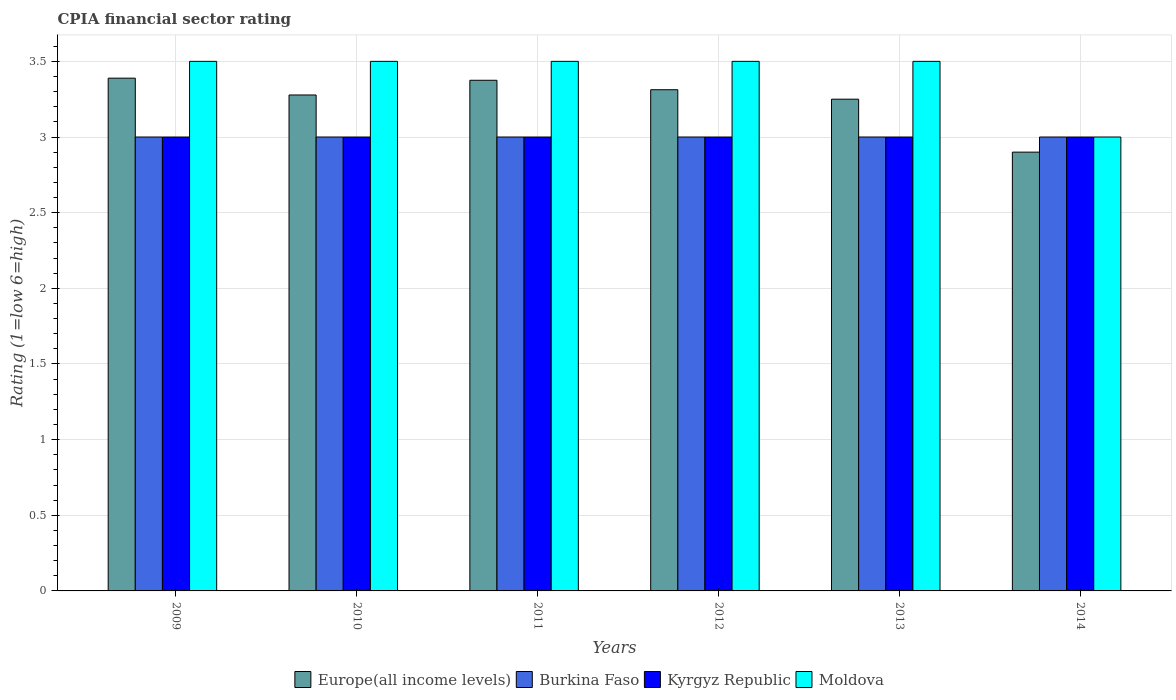How many groups of bars are there?
Offer a very short reply. 6. Are the number of bars per tick equal to the number of legend labels?
Offer a very short reply. Yes. Are the number of bars on each tick of the X-axis equal?
Your answer should be very brief. Yes. Across all years, what is the maximum CPIA rating in Burkina Faso?
Provide a succinct answer. 3. In which year was the CPIA rating in Burkina Faso maximum?
Your response must be concise. 2009. What is the total CPIA rating in Kyrgyz Republic in the graph?
Give a very brief answer. 18. What is the average CPIA rating in Moldova per year?
Provide a succinct answer. 3.42. What is the ratio of the CPIA rating in Kyrgyz Republic in 2009 to that in 2010?
Your answer should be compact. 1. Is the difference between the CPIA rating in Burkina Faso in 2010 and 2013 greater than the difference between the CPIA rating in Europe(all income levels) in 2010 and 2013?
Ensure brevity in your answer.  No. What is the difference between the highest and the second highest CPIA rating in Burkina Faso?
Provide a short and direct response. 0. What is the difference between the highest and the lowest CPIA rating in Europe(all income levels)?
Offer a terse response. 0.49. Is it the case that in every year, the sum of the CPIA rating in Kyrgyz Republic and CPIA rating in Moldova is greater than the sum of CPIA rating in Burkina Faso and CPIA rating in Europe(all income levels)?
Give a very brief answer. No. What does the 3rd bar from the left in 2012 represents?
Make the answer very short. Kyrgyz Republic. What does the 4th bar from the right in 2011 represents?
Your answer should be compact. Europe(all income levels). Is it the case that in every year, the sum of the CPIA rating in Moldova and CPIA rating in Europe(all income levels) is greater than the CPIA rating in Kyrgyz Republic?
Your answer should be compact. Yes. How many bars are there?
Ensure brevity in your answer.  24. How many years are there in the graph?
Give a very brief answer. 6. How many legend labels are there?
Make the answer very short. 4. What is the title of the graph?
Offer a very short reply. CPIA financial sector rating. What is the label or title of the Y-axis?
Keep it short and to the point. Rating (1=low 6=high). What is the Rating (1=low 6=high) of Europe(all income levels) in 2009?
Your answer should be compact. 3.39. What is the Rating (1=low 6=high) in Kyrgyz Republic in 2009?
Provide a succinct answer. 3. What is the Rating (1=low 6=high) in Moldova in 2009?
Provide a short and direct response. 3.5. What is the Rating (1=low 6=high) in Europe(all income levels) in 2010?
Ensure brevity in your answer.  3.28. What is the Rating (1=low 6=high) in Burkina Faso in 2010?
Offer a terse response. 3. What is the Rating (1=low 6=high) in Moldova in 2010?
Offer a terse response. 3.5. What is the Rating (1=low 6=high) in Europe(all income levels) in 2011?
Your answer should be compact. 3.38. What is the Rating (1=low 6=high) of Moldova in 2011?
Your answer should be compact. 3.5. What is the Rating (1=low 6=high) of Europe(all income levels) in 2012?
Ensure brevity in your answer.  3.31. What is the Rating (1=low 6=high) of Kyrgyz Republic in 2012?
Offer a very short reply. 3. What is the Rating (1=low 6=high) of Europe(all income levels) in 2013?
Ensure brevity in your answer.  3.25. What is the Rating (1=low 6=high) of Kyrgyz Republic in 2013?
Your answer should be very brief. 3. What is the Rating (1=low 6=high) of Moldova in 2013?
Make the answer very short. 3.5. What is the Rating (1=low 6=high) of Europe(all income levels) in 2014?
Make the answer very short. 2.9. What is the Rating (1=low 6=high) in Burkina Faso in 2014?
Provide a short and direct response. 3. What is the Rating (1=low 6=high) in Kyrgyz Republic in 2014?
Your answer should be very brief. 3. Across all years, what is the maximum Rating (1=low 6=high) in Europe(all income levels)?
Ensure brevity in your answer.  3.39. Across all years, what is the maximum Rating (1=low 6=high) of Kyrgyz Republic?
Provide a succinct answer. 3. Across all years, what is the maximum Rating (1=low 6=high) of Moldova?
Give a very brief answer. 3.5. Across all years, what is the minimum Rating (1=low 6=high) in Europe(all income levels)?
Your response must be concise. 2.9. What is the total Rating (1=low 6=high) of Europe(all income levels) in the graph?
Provide a succinct answer. 19.5. What is the total Rating (1=low 6=high) in Burkina Faso in the graph?
Offer a very short reply. 18. What is the difference between the Rating (1=low 6=high) in Kyrgyz Republic in 2009 and that in 2010?
Your response must be concise. 0. What is the difference between the Rating (1=low 6=high) in Moldova in 2009 and that in 2010?
Your response must be concise. 0. What is the difference between the Rating (1=low 6=high) in Europe(all income levels) in 2009 and that in 2011?
Your response must be concise. 0.01. What is the difference between the Rating (1=low 6=high) of Moldova in 2009 and that in 2011?
Provide a succinct answer. 0. What is the difference between the Rating (1=low 6=high) in Europe(all income levels) in 2009 and that in 2012?
Offer a terse response. 0.08. What is the difference between the Rating (1=low 6=high) in Burkina Faso in 2009 and that in 2012?
Offer a very short reply. 0. What is the difference between the Rating (1=low 6=high) in Kyrgyz Republic in 2009 and that in 2012?
Keep it short and to the point. 0. What is the difference between the Rating (1=low 6=high) of Moldova in 2009 and that in 2012?
Your answer should be compact. 0. What is the difference between the Rating (1=low 6=high) of Europe(all income levels) in 2009 and that in 2013?
Keep it short and to the point. 0.14. What is the difference between the Rating (1=low 6=high) of Burkina Faso in 2009 and that in 2013?
Your response must be concise. 0. What is the difference between the Rating (1=low 6=high) of Moldova in 2009 and that in 2013?
Keep it short and to the point. 0. What is the difference between the Rating (1=low 6=high) of Europe(all income levels) in 2009 and that in 2014?
Offer a terse response. 0.49. What is the difference between the Rating (1=low 6=high) in Burkina Faso in 2009 and that in 2014?
Offer a very short reply. 0. What is the difference between the Rating (1=low 6=high) in Europe(all income levels) in 2010 and that in 2011?
Your answer should be compact. -0.1. What is the difference between the Rating (1=low 6=high) in Burkina Faso in 2010 and that in 2011?
Offer a very short reply. 0. What is the difference between the Rating (1=low 6=high) of Kyrgyz Republic in 2010 and that in 2011?
Your answer should be compact. 0. What is the difference between the Rating (1=low 6=high) of Moldova in 2010 and that in 2011?
Offer a terse response. 0. What is the difference between the Rating (1=low 6=high) in Europe(all income levels) in 2010 and that in 2012?
Your answer should be very brief. -0.03. What is the difference between the Rating (1=low 6=high) of Kyrgyz Republic in 2010 and that in 2012?
Your answer should be very brief. 0. What is the difference between the Rating (1=low 6=high) of Europe(all income levels) in 2010 and that in 2013?
Your answer should be very brief. 0.03. What is the difference between the Rating (1=low 6=high) of Kyrgyz Republic in 2010 and that in 2013?
Your response must be concise. 0. What is the difference between the Rating (1=low 6=high) in Moldova in 2010 and that in 2013?
Offer a very short reply. 0. What is the difference between the Rating (1=low 6=high) of Europe(all income levels) in 2010 and that in 2014?
Offer a very short reply. 0.38. What is the difference between the Rating (1=low 6=high) in Burkina Faso in 2010 and that in 2014?
Make the answer very short. 0. What is the difference between the Rating (1=low 6=high) of Kyrgyz Republic in 2010 and that in 2014?
Provide a short and direct response. 0. What is the difference between the Rating (1=low 6=high) of Moldova in 2010 and that in 2014?
Ensure brevity in your answer.  0.5. What is the difference between the Rating (1=low 6=high) of Europe(all income levels) in 2011 and that in 2012?
Your answer should be compact. 0.06. What is the difference between the Rating (1=low 6=high) of Burkina Faso in 2011 and that in 2012?
Make the answer very short. 0. What is the difference between the Rating (1=low 6=high) of Europe(all income levels) in 2011 and that in 2013?
Provide a succinct answer. 0.12. What is the difference between the Rating (1=low 6=high) in Burkina Faso in 2011 and that in 2013?
Provide a short and direct response. 0. What is the difference between the Rating (1=low 6=high) of Kyrgyz Republic in 2011 and that in 2013?
Provide a succinct answer. 0. What is the difference between the Rating (1=low 6=high) in Moldova in 2011 and that in 2013?
Keep it short and to the point. 0. What is the difference between the Rating (1=low 6=high) of Europe(all income levels) in 2011 and that in 2014?
Keep it short and to the point. 0.47. What is the difference between the Rating (1=low 6=high) of Kyrgyz Republic in 2011 and that in 2014?
Provide a short and direct response. 0. What is the difference between the Rating (1=low 6=high) of Moldova in 2011 and that in 2014?
Your response must be concise. 0.5. What is the difference between the Rating (1=low 6=high) of Europe(all income levels) in 2012 and that in 2013?
Offer a terse response. 0.06. What is the difference between the Rating (1=low 6=high) in Moldova in 2012 and that in 2013?
Offer a very short reply. 0. What is the difference between the Rating (1=low 6=high) of Europe(all income levels) in 2012 and that in 2014?
Make the answer very short. 0.41. What is the difference between the Rating (1=low 6=high) in Kyrgyz Republic in 2012 and that in 2014?
Provide a short and direct response. 0. What is the difference between the Rating (1=low 6=high) in Moldova in 2012 and that in 2014?
Keep it short and to the point. 0.5. What is the difference between the Rating (1=low 6=high) of Europe(all income levels) in 2013 and that in 2014?
Ensure brevity in your answer.  0.35. What is the difference between the Rating (1=low 6=high) in Burkina Faso in 2013 and that in 2014?
Give a very brief answer. 0. What is the difference between the Rating (1=low 6=high) in Moldova in 2013 and that in 2014?
Ensure brevity in your answer.  0.5. What is the difference between the Rating (1=low 6=high) of Europe(all income levels) in 2009 and the Rating (1=low 6=high) of Burkina Faso in 2010?
Offer a terse response. 0.39. What is the difference between the Rating (1=low 6=high) of Europe(all income levels) in 2009 and the Rating (1=low 6=high) of Kyrgyz Republic in 2010?
Your answer should be compact. 0.39. What is the difference between the Rating (1=low 6=high) in Europe(all income levels) in 2009 and the Rating (1=low 6=high) in Moldova in 2010?
Keep it short and to the point. -0.11. What is the difference between the Rating (1=low 6=high) in Burkina Faso in 2009 and the Rating (1=low 6=high) in Kyrgyz Republic in 2010?
Your answer should be very brief. 0. What is the difference between the Rating (1=low 6=high) in Europe(all income levels) in 2009 and the Rating (1=low 6=high) in Burkina Faso in 2011?
Your answer should be very brief. 0.39. What is the difference between the Rating (1=low 6=high) of Europe(all income levels) in 2009 and the Rating (1=low 6=high) of Kyrgyz Republic in 2011?
Make the answer very short. 0.39. What is the difference between the Rating (1=low 6=high) in Europe(all income levels) in 2009 and the Rating (1=low 6=high) in Moldova in 2011?
Your response must be concise. -0.11. What is the difference between the Rating (1=low 6=high) in Kyrgyz Republic in 2009 and the Rating (1=low 6=high) in Moldova in 2011?
Make the answer very short. -0.5. What is the difference between the Rating (1=low 6=high) of Europe(all income levels) in 2009 and the Rating (1=low 6=high) of Burkina Faso in 2012?
Keep it short and to the point. 0.39. What is the difference between the Rating (1=low 6=high) in Europe(all income levels) in 2009 and the Rating (1=low 6=high) in Kyrgyz Republic in 2012?
Ensure brevity in your answer.  0.39. What is the difference between the Rating (1=low 6=high) in Europe(all income levels) in 2009 and the Rating (1=low 6=high) in Moldova in 2012?
Make the answer very short. -0.11. What is the difference between the Rating (1=low 6=high) of Burkina Faso in 2009 and the Rating (1=low 6=high) of Kyrgyz Republic in 2012?
Offer a terse response. 0. What is the difference between the Rating (1=low 6=high) in Kyrgyz Republic in 2009 and the Rating (1=low 6=high) in Moldova in 2012?
Your answer should be very brief. -0.5. What is the difference between the Rating (1=low 6=high) of Europe(all income levels) in 2009 and the Rating (1=low 6=high) of Burkina Faso in 2013?
Make the answer very short. 0.39. What is the difference between the Rating (1=low 6=high) of Europe(all income levels) in 2009 and the Rating (1=low 6=high) of Kyrgyz Republic in 2013?
Your answer should be very brief. 0.39. What is the difference between the Rating (1=low 6=high) in Europe(all income levels) in 2009 and the Rating (1=low 6=high) in Moldova in 2013?
Offer a terse response. -0.11. What is the difference between the Rating (1=low 6=high) in Europe(all income levels) in 2009 and the Rating (1=low 6=high) in Burkina Faso in 2014?
Give a very brief answer. 0.39. What is the difference between the Rating (1=low 6=high) of Europe(all income levels) in 2009 and the Rating (1=low 6=high) of Kyrgyz Republic in 2014?
Offer a very short reply. 0.39. What is the difference between the Rating (1=low 6=high) of Europe(all income levels) in 2009 and the Rating (1=low 6=high) of Moldova in 2014?
Your response must be concise. 0.39. What is the difference between the Rating (1=low 6=high) of Burkina Faso in 2009 and the Rating (1=low 6=high) of Kyrgyz Republic in 2014?
Provide a short and direct response. 0. What is the difference between the Rating (1=low 6=high) in Burkina Faso in 2009 and the Rating (1=low 6=high) in Moldova in 2014?
Make the answer very short. 0. What is the difference between the Rating (1=low 6=high) of Kyrgyz Republic in 2009 and the Rating (1=low 6=high) of Moldova in 2014?
Make the answer very short. 0. What is the difference between the Rating (1=low 6=high) in Europe(all income levels) in 2010 and the Rating (1=low 6=high) in Burkina Faso in 2011?
Your answer should be compact. 0.28. What is the difference between the Rating (1=low 6=high) in Europe(all income levels) in 2010 and the Rating (1=low 6=high) in Kyrgyz Republic in 2011?
Provide a succinct answer. 0.28. What is the difference between the Rating (1=low 6=high) in Europe(all income levels) in 2010 and the Rating (1=low 6=high) in Moldova in 2011?
Your answer should be very brief. -0.22. What is the difference between the Rating (1=low 6=high) of Burkina Faso in 2010 and the Rating (1=low 6=high) of Moldova in 2011?
Your answer should be very brief. -0.5. What is the difference between the Rating (1=low 6=high) of Europe(all income levels) in 2010 and the Rating (1=low 6=high) of Burkina Faso in 2012?
Make the answer very short. 0.28. What is the difference between the Rating (1=low 6=high) in Europe(all income levels) in 2010 and the Rating (1=low 6=high) in Kyrgyz Republic in 2012?
Your response must be concise. 0.28. What is the difference between the Rating (1=low 6=high) of Europe(all income levels) in 2010 and the Rating (1=low 6=high) of Moldova in 2012?
Make the answer very short. -0.22. What is the difference between the Rating (1=low 6=high) of Burkina Faso in 2010 and the Rating (1=low 6=high) of Moldova in 2012?
Keep it short and to the point. -0.5. What is the difference between the Rating (1=low 6=high) in Kyrgyz Republic in 2010 and the Rating (1=low 6=high) in Moldova in 2012?
Offer a terse response. -0.5. What is the difference between the Rating (1=low 6=high) of Europe(all income levels) in 2010 and the Rating (1=low 6=high) of Burkina Faso in 2013?
Your answer should be compact. 0.28. What is the difference between the Rating (1=low 6=high) of Europe(all income levels) in 2010 and the Rating (1=low 6=high) of Kyrgyz Republic in 2013?
Offer a terse response. 0.28. What is the difference between the Rating (1=low 6=high) in Europe(all income levels) in 2010 and the Rating (1=low 6=high) in Moldova in 2013?
Offer a very short reply. -0.22. What is the difference between the Rating (1=low 6=high) of Burkina Faso in 2010 and the Rating (1=low 6=high) of Kyrgyz Republic in 2013?
Offer a terse response. 0. What is the difference between the Rating (1=low 6=high) in Burkina Faso in 2010 and the Rating (1=low 6=high) in Moldova in 2013?
Your answer should be very brief. -0.5. What is the difference between the Rating (1=low 6=high) of Europe(all income levels) in 2010 and the Rating (1=low 6=high) of Burkina Faso in 2014?
Your response must be concise. 0.28. What is the difference between the Rating (1=low 6=high) in Europe(all income levels) in 2010 and the Rating (1=low 6=high) in Kyrgyz Republic in 2014?
Your response must be concise. 0.28. What is the difference between the Rating (1=low 6=high) in Europe(all income levels) in 2010 and the Rating (1=low 6=high) in Moldova in 2014?
Offer a very short reply. 0.28. What is the difference between the Rating (1=low 6=high) of Burkina Faso in 2010 and the Rating (1=low 6=high) of Kyrgyz Republic in 2014?
Offer a terse response. 0. What is the difference between the Rating (1=low 6=high) in Kyrgyz Republic in 2010 and the Rating (1=low 6=high) in Moldova in 2014?
Offer a very short reply. 0. What is the difference between the Rating (1=low 6=high) in Europe(all income levels) in 2011 and the Rating (1=low 6=high) in Burkina Faso in 2012?
Make the answer very short. 0.38. What is the difference between the Rating (1=low 6=high) in Europe(all income levels) in 2011 and the Rating (1=low 6=high) in Moldova in 2012?
Keep it short and to the point. -0.12. What is the difference between the Rating (1=low 6=high) of Kyrgyz Republic in 2011 and the Rating (1=low 6=high) of Moldova in 2012?
Make the answer very short. -0.5. What is the difference between the Rating (1=low 6=high) in Europe(all income levels) in 2011 and the Rating (1=low 6=high) in Kyrgyz Republic in 2013?
Provide a short and direct response. 0.38. What is the difference between the Rating (1=low 6=high) of Europe(all income levels) in 2011 and the Rating (1=low 6=high) of Moldova in 2013?
Offer a very short reply. -0.12. What is the difference between the Rating (1=low 6=high) in Burkina Faso in 2011 and the Rating (1=low 6=high) in Kyrgyz Republic in 2013?
Offer a terse response. 0. What is the difference between the Rating (1=low 6=high) in Burkina Faso in 2011 and the Rating (1=low 6=high) in Moldova in 2013?
Keep it short and to the point. -0.5. What is the difference between the Rating (1=low 6=high) of Kyrgyz Republic in 2011 and the Rating (1=low 6=high) of Moldova in 2013?
Offer a terse response. -0.5. What is the difference between the Rating (1=low 6=high) of Europe(all income levels) in 2011 and the Rating (1=low 6=high) of Kyrgyz Republic in 2014?
Offer a very short reply. 0.38. What is the difference between the Rating (1=low 6=high) of Burkina Faso in 2011 and the Rating (1=low 6=high) of Kyrgyz Republic in 2014?
Offer a terse response. 0. What is the difference between the Rating (1=low 6=high) of Europe(all income levels) in 2012 and the Rating (1=low 6=high) of Burkina Faso in 2013?
Make the answer very short. 0.31. What is the difference between the Rating (1=low 6=high) in Europe(all income levels) in 2012 and the Rating (1=low 6=high) in Kyrgyz Republic in 2013?
Make the answer very short. 0.31. What is the difference between the Rating (1=low 6=high) in Europe(all income levels) in 2012 and the Rating (1=low 6=high) in Moldova in 2013?
Keep it short and to the point. -0.19. What is the difference between the Rating (1=low 6=high) in Burkina Faso in 2012 and the Rating (1=low 6=high) in Moldova in 2013?
Offer a terse response. -0.5. What is the difference between the Rating (1=low 6=high) of Europe(all income levels) in 2012 and the Rating (1=low 6=high) of Burkina Faso in 2014?
Provide a short and direct response. 0.31. What is the difference between the Rating (1=low 6=high) of Europe(all income levels) in 2012 and the Rating (1=low 6=high) of Kyrgyz Republic in 2014?
Keep it short and to the point. 0.31. What is the difference between the Rating (1=low 6=high) of Europe(all income levels) in 2012 and the Rating (1=low 6=high) of Moldova in 2014?
Provide a succinct answer. 0.31. What is the difference between the Rating (1=low 6=high) of Burkina Faso in 2012 and the Rating (1=low 6=high) of Kyrgyz Republic in 2014?
Keep it short and to the point. 0. What is the difference between the Rating (1=low 6=high) in Kyrgyz Republic in 2012 and the Rating (1=low 6=high) in Moldova in 2014?
Offer a very short reply. 0. What is the difference between the Rating (1=low 6=high) of Europe(all income levels) in 2013 and the Rating (1=low 6=high) of Kyrgyz Republic in 2014?
Your answer should be compact. 0.25. What is the difference between the Rating (1=low 6=high) in Burkina Faso in 2013 and the Rating (1=low 6=high) in Moldova in 2014?
Provide a succinct answer. 0. What is the average Rating (1=low 6=high) in Europe(all income levels) per year?
Your answer should be very brief. 3.25. What is the average Rating (1=low 6=high) in Moldova per year?
Ensure brevity in your answer.  3.42. In the year 2009, what is the difference between the Rating (1=low 6=high) of Europe(all income levels) and Rating (1=low 6=high) of Burkina Faso?
Give a very brief answer. 0.39. In the year 2009, what is the difference between the Rating (1=low 6=high) in Europe(all income levels) and Rating (1=low 6=high) in Kyrgyz Republic?
Offer a very short reply. 0.39. In the year 2009, what is the difference between the Rating (1=low 6=high) in Europe(all income levels) and Rating (1=low 6=high) in Moldova?
Your answer should be very brief. -0.11. In the year 2009, what is the difference between the Rating (1=low 6=high) of Burkina Faso and Rating (1=low 6=high) of Moldova?
Provide a short and direct response. -0.5. In the year 2010, what is the difference between the Rating (1=low 6=high) of Europe(all income levels) and Rating (1=low 6=high) of Burkina Faso?
Provide a succinct answer. 0.28. In the year 2010, what is the difference between the Rating (1=low 6=high) of Europe(all income levels) and Rating (1=low 6=high) of Kyrgyz Republic?
Ensure brevity in your answer.  0.28. In the year 2010, what is the difference between the Rating (1=low 6=high) in Europe(all income levels) and Rating (1=low 6=high) in Moldova?
Give a very brief answer. -0.22. In the year 2010, what is the difference between the Rating (1=low 6=high) of Burkina Faso and Rating (1=low 6=high) of Kyrgyz Republic?
Your answer should be very brief. 0. In the year 2010, what is the difference between the Rating (1=low 6=high) of Burkina Faso and Rating (1=low 6=high) of Moldova?
Your answer should be compact. -0.5. In the year 2010, what is the difference between the Rating (1=low 6=high) in Kyrgyz Republic and Rating (1=low 6=high) in Moldova?
Keep it short and to the point. -0.5. In the year 2011, what is the difference between the Rating (1=low 6=high) of Europe(all income levels) and Rating (1=low 6=high) of Burkina Faso?
Provide a short and direct response. 0.38. In the year 2011, what is the difference between the Rating (1=low 6=high) in Europe(all income levels) and Rating (1=low 6=high) in Kyrgyz Republic?
Keep it short and to the point. 0.38. In the year 2011, what is the difference between the Rating (1=low 6=high) of Europe(all income levels) and Rating (1=low 6=high) of Moldova?
Offer a very short reply. -0.12. In the year 2011, what is the difference between the Rating (1=low 6=high) of Burkina Faso and Rating (1=low 6=high) of Kyrgyz Republic?
Your answer should be very brief. 0. In the year 2011, what is the difference between the Rating (1=low 6=high) of Kyrgyz Republic and Rating (1=low 6=high) of Moldova?
Your response must be concise. -0.5. In the year 2012, what is the difference between the Rating (1=low 6=high) in Europe(all income levels) and Rating (1=low 6=high) in Burkina Faso?
Your answer should be very brief. 0.31. In the year 2012, what is the difference between the Rating (1=low 6=high) of Europe(all income levels) and Rating (1=low 6=high) of Kyrgyz Republic?
Give a very brief answer. 0.31. In the year 2012, what is the difference between the Rating (1=low 6=high) in Europe(all income levels) and Rating (1=low 6=high) in Moldova?
Offer a very short reply. -0.19. In the year 2012, what is the difference between the Rating (1=low 6=high) in Burkina Faso and Rating (1=low 6=high) in Moldova?
Your response must be concise. -0.5. In the year 2013, what is the difference between the Rating (1=low 6=high) in Europe(all income levels) and Rating (1=low 6=high) in Burkina Faso?
Offer a very short reply. 0.25. In the year 2013, what is the difference between the Rating (1=low 6=high) in Europe(all income levels) and Rating (1=low 6=high) in Moldova?
Your response must be concise. -0.25. In the year 2013, what is the difference between the Rating (1=low 6=high) in Burkina Faso and Rating (1=low 6=high) in Kyrgyz Republic?
Keep it short and to the point. 0. In the year 2013, what is the difference between the Rating (1=low 6=high) of Burkina Faso and Rating (1=low 6=high) of Moldova?
Your answer should be very brief. -0.5. In the year 2014, what is the difference between the Rating (1=low 6=high) in Europe(all income levels) and Rating (1=low 6=high) in Kyrgyz Republic?
Make the answer very short. -0.1. What is the ratio of the Rating (1=low 6=high) of Europe(all income levels) in 2009 to that in 2010?
Your response must be concise. 1.03. What is the ratio of the Rating (1=low 6=high) in Burkina Faso in 2009 to that in 2010?
Give a very brief answer. 1. What is the ratio of the Rating (1=low 6=high) of Kyrgyz Republic in 2009 to that in 2010?
Your answer should be compact. 1. What is the ratio of the Rating (1=low 6=high) in Moldova in 2009 to that in 2010?
Your answer should be very brief. 1. What is the ratio of the Rating (1=low 6=high) in Europe(all income levels) in 2009 to that in 2011?
Offer a very short reply. 1. What is the ratio of the Rating (1=low 6=high) of Burkina Faso in 2009 to that in 2011?
Give a very brief answer. 1. What is the ratio of the Rating (1=low 6=high) of Kyrgyz Republic in 2009 to that in 2011?
Make the answer very short. 1. What is the ratio of the Rating (1=low 6=high) in Moldova in 2009 to that in 2011?
Give a very brief answer. 1. What is the ratio of the Rating (1=low 6=high) of Europe(all income levels) in 2009 to that in 2012?
Give a very brief answer. 1.02. What is the ratio of the Rating (1=low 6=high) in Moldova in 2009 to that in 2012?
Keep it short and to the point. 1. What is the ratio of the Rating (1=low 6=high) of Europe(all income levels) in 2009 to that in 2013?
Offer a very short reply. 1.04. What is the ratio of the Rating (1=low 6=high) of Burkina Faso in 2009 to that in 2013?
Your answer should be compact. 1. What is the ratio of the Rating (1=low 6=high) in Kyrgyz Republic in 2009 to that in 2013?
Offer a very short reply. 1. What is the ratio of the Rating (1=low 6=high) in Moldova in 2009 to that in 2013?
Offer a very short reply. 1. What is the ratio of the Rating (1=low 6=high) of Europe(all income levels) in 2009 to that in 2014?
Offer a terse response. 1.17. What is the ratio of the Rating (1=low 6=high) of Kyrgyz Republic in 2009 to that in 2014?
Make the answer very short. 1. What is the ratio of the Rating (1=low 6=high) in Europe(all income levels) in 2010 to that in 2011?
Provide a succinct answer. 0.97. What is the ratio of the Rating (1=low 6=high) in Moldova in 2010 to that in 2011?
Ensure brevity in your answer.  1. What is the ratio of the Rating (1=low 6=high) of Europe(all income levels) in 2010 to that in 2012?
Provide a succinct answer. 0.99. What is the ratio of the Rating (1=low 6=high) of Kyrgyz Republic in 2010 to that in 2012?
Offer a terse response. 1. What is the ratio of the Rating (1=low 6=high) in Europe(all income levels) in 2010 to that in 2013?
Your answer should be very brief. 1.01. What is the ratio of the Rating (1=low 6=high) in Burkina Faso in 2010 to that in 2013?
Keep it short and to the point. 1. What is the ratio of the Rating (1=low 6=high) in Moldova in 2010 to that in 2013?
Offer a terse response. 1. What is the ratio of the Rating (1=low 6=high) in Europe(all income levels) in 2010 to that in 2014?
Keep it short and to the point. 1.13. What is the ratio of the Rating (1=low 6=high) in Burkina Faso in 2010 to that in 2014?
Offer a terse response. 1. What is the ratio of the Rating (1=low 6=high) of Moldova in 2010 to that in 2014?
Make the answer very short. 1.17. What is the ratio of the Rating (1=low 6=high) of Europe(all income levels) in 2011 to that in 2012?
Offer a terse response. 1.02. What is the ratio of the Rating (1=low 6=high) of Europe(all income levels) in 2011 to that in 2013?
Offer a very short reply. 1.04. What is the ratio of the Rating (1=low 6=high) in Kyrgyz Republic in 2011 to that in 2013?
Make the answer very short. 1. What is the ratio of the Rating (1=low 6=high) of Europe(all income levels) in 2011 to that in 2014?
Your answer should be very brief. 1.16. What is the ratio of the Rating (1=low 6=high) of Burkina Faso in 2011 to that in 2014?
Keep it short and to the point. 1. What is the ratio of the Rating (1=low 6=high) in Kyrgyz Republic in 2011 to that in 2014?
Ensure brevity in your answer.  1. What is the ratio of the Rating (1=low 6=high) in Moldova in 2011 to that in 2014?
Ensure brevity in your answer.  1.17. What is the ratio of the Rating (1=low 6=high) in Europe(all income levels) in 2012 to that in 2013?
Make the answer very short. 1.02. What is the ratio of the Rating (1=low 6=high) in Burkina Faso in 2012 to that in 2013?
Provide a short and direct response. 1. What is the ratio of the Rating (1=low 6=high) in Europe(all income levels) in 2012 to that in 2014?
Offer a very short reply. 1.14. What is the ratio of the Rating (1=low 6=high) in Burkina Faso in 2012 to that in 2014?
Your answer should be very brief. 1. What is the ratio of the Rating (1=low 6=high) of Kyrgyz Republic in 2012 to that in 2014?
Make the answer very short. 1. What is the ratio of the Rating (1=low 6=high) of Moldova in 2012 to that in 2014?
Your answer should be very brief. 1.17. What is the ratio of the Rating (1=low 6=high) in Europe(all income levels) in 2013 to that in 2014?
Give a very brief answer. 1.12. What is the ratio of the Rating (1=low 6=high) of Burkina Faso in 2013 to that in 2014?
Give a very brief answer. 1. What is the difference between the highest and the second highest Rating (1=low 6=high) in Europe(all income levels)?
Give a very brief answer. 0.01. What is the difference between the highest and the second highest Rating (1=low 6=high) in Burkina Faso?
Offer a terse response. 0. What is the difference between the highest and the second highest Rating (1=low 6=high) of Moldova?
Keep it short and to the point. 0. What is the difference between the highest and the lowest Rating (1=low 6=high) of Europe(all income levels)?
Ensure brevity in your answer.  0.49. 